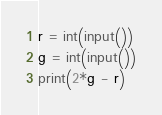<code> <loc_0><loc_0><loc_500><loc_500><_Python_>r = int(input())
g = int(input())
print(2*g - r)</code> 